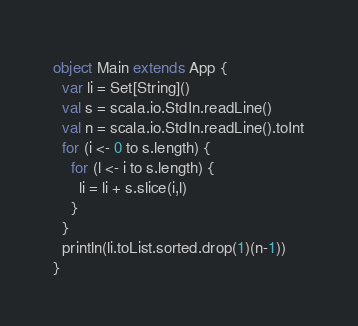Convert code to text. <code><loc_0><loc_0><loc_500><loc_500><_Scala_>object Main extends App {
  var li = Set[String]()
  val s = scala.io.StdIn.readLine()
  val n = scala.io.StdIn.readLine().toInt
  for (i <- 0 to s.length) {
    for (l <- i to s.length) {
      li = li + s.slice(i,l)
    }
  }
  println(li.toList.sorted.drop(1)(n-1))
}</code> 